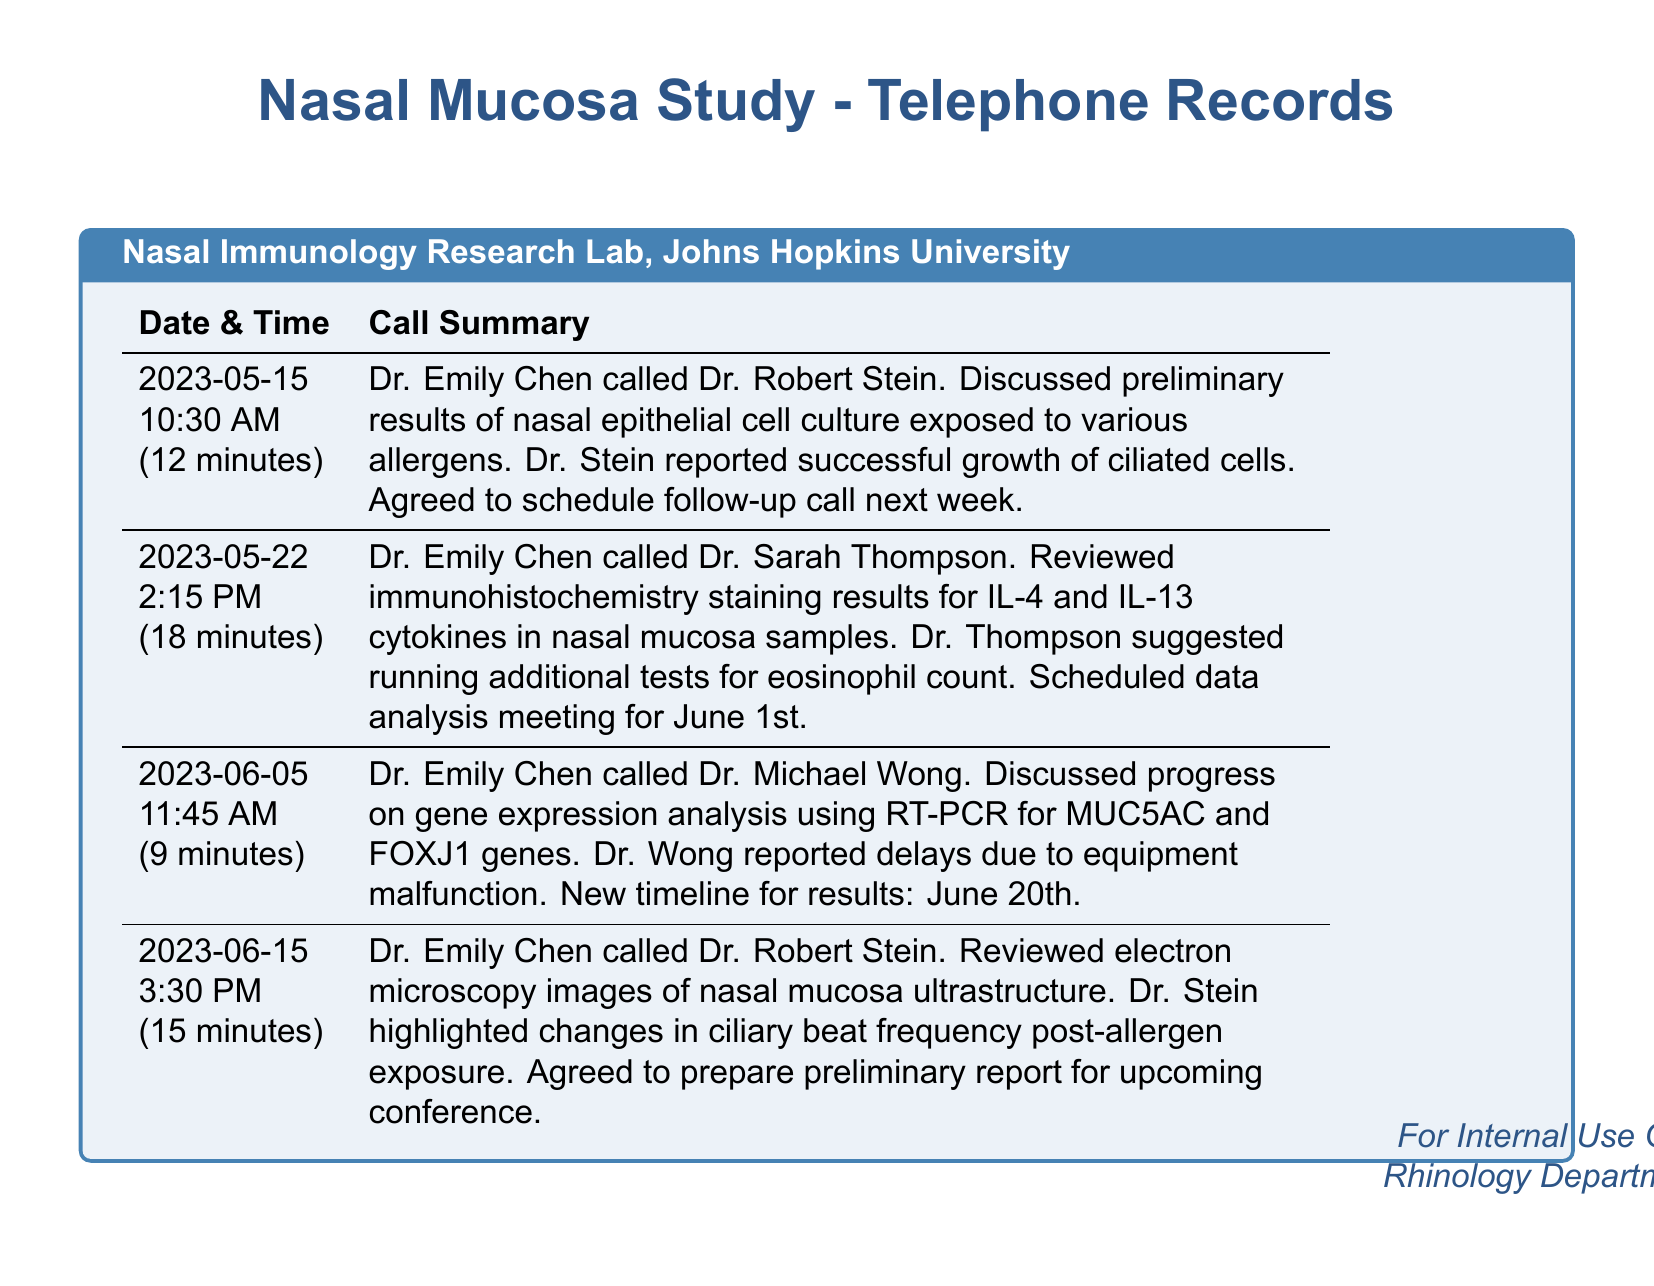What date did Dr. Emily Chen call Dr. Robert Stein? The document lists the date of the call as May 15th, 2023, during which Dr. Chen contacted Dr. Stein.
Answer: May 15th, 2023 What was discussed during the call on June 5th? The summary states that Dr. Emily Chen and Dr. Michael Wong discussed gene expression analysis using RT-PCR.
Answer: Gene expression analysis using RT-PCR How long was the call on May 22nd? The call duration is mentioned in the document and was recorded as 18 minutes.
Answer: 18 minutes Who suggested running additional tests for eosinophil count? The document indicates that Dr. Sarah Thompson made this suggestion during the call on May 22nd.
Answer: Dr. Sarah Thompson What is the new timeline for results after the equipment malfunction? The timeline for results was pushed to June 20th, as noted in the summary of the conversation on June 5th.
Answer: June 20th What cytokines were discussed in relation to nasal mucosa samples? Dr. Emily Chen and Dr. Sarah Thompson discussed IL-4 and IL-13 cytokines during their call on May 22nd.
Answer: IL-4 and IL-13 What type of images did Dr. Emily Chen review with Dr. Robert Stein? The call on June 15th involved reviewing electron microscopy images of nasal mucosa ultrastructure.
Answer: Electron microscopy images How many calls did Dr. Emily Chen make regarding the nasal mucosa study? The document lists four distinct telephone records, indicating the number of calls made.
Answer: Four calls 